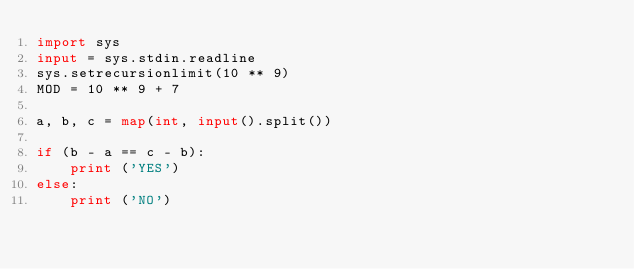Convert code to text. <code><loc_0><loc_0><loc_500><loc_500><_Python_>import sys
input = sys.stdin.readline
sys.setrecursionlimit(10 ** 9)
MOD = 10 ** 9 + 7

a, b, c = map(int, input().split())

if (b - a == c - b):
    print ('YES')
else:
    print ('NO')</code> 